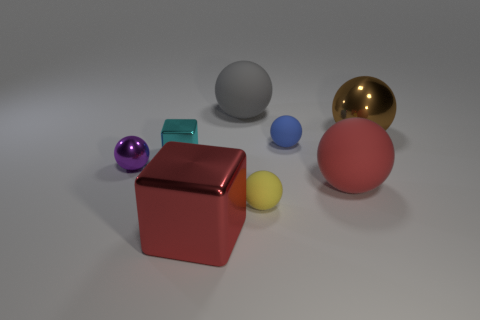What is the color of the tiny object that is the same material as the tiny blue ball?
Give a very brief answer. Yellow. The big ball to the left of the large sphere in front of the tiny sphere left of the big metal block is made of what material?
Your answer should be compact. Rubber. There is a red object that is left of the gray rubber object; is it the same size as the gray matte sphere?
Your response must be concise. Yes. How many big things are either blue matte cylinders or shiny spheres?
Your response must be concise. 1. Is there a object that has the same color as the big shiny block?
Keep it short and to the point. Yes. There is another metal thing that is the same size as the cyan metal object; what shape is it?
Give a very brief answer. Sphere. Is the color of the large rubber ball right of the blue matte object the same as the large cube?
Offer a terse response. Yes. What number of things are small metallic objects that are left of the tiny cyan metal block or small metallic things?
Give a very brief answer. 2. Are there more small cyan metal blocks on the left side of the yellow sphere than yellow rubber objects behind the small cyan metallic cube?
Offer a terse response. Yes. Is the yellow ball made of the same material as the large red block?
Offer a terse response. No. 